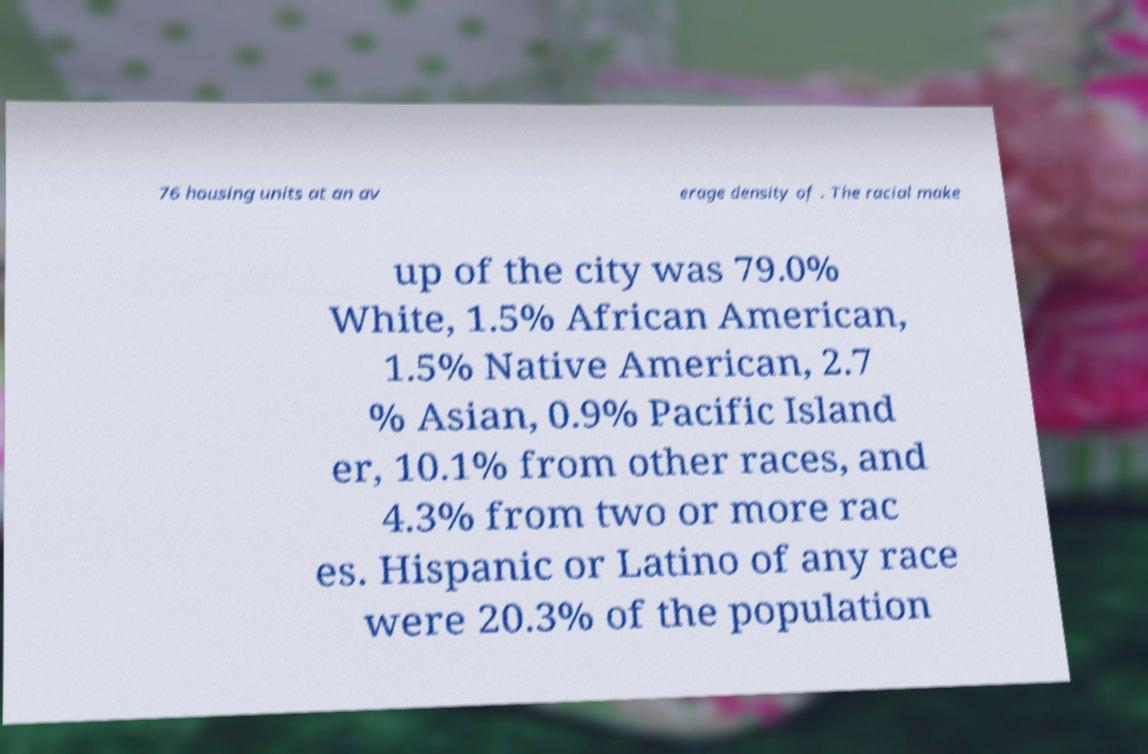Can you read and provide the text displayed in the image?This photo seems to have some interesting text. Can you extract and type it out for me? 76 housing units at an av erage density of . The racial make up of the city was 79.0% White, 1.5% African American, 1.5% Native American, 2.7 % Asian, 0.9% Pacific Island er, 10.1% from other races, and 4.3% from two or more rac es. Hispanic or Latino of any race were 20.3% of the population 